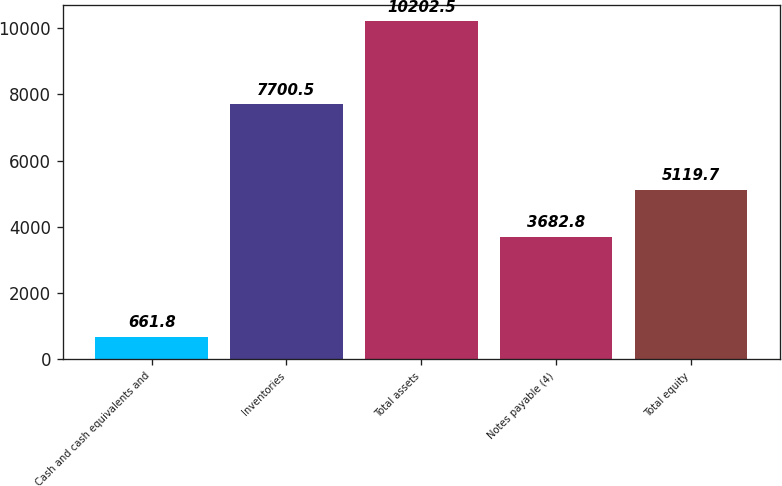Convert chart to OTSL. <chart><loc_0><loc_0><loc_500><loc_500><bar_chart><fcel>Cash and cash equivalents and<fcel>Inventories<fcel>Total assets<fcel>Notes payable (4)<fcel>Total equity<nl><fcel>661.8<fcel>7700.5<fcel>10202.5<fcel>3682.8<fcel>5119.7<nl></chart> 